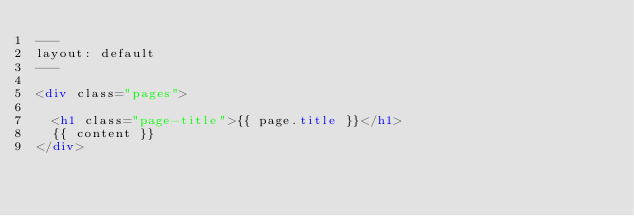Convert code to text. <code><loc_0><loc_0><loc_500><loc_500><_HTML_>---
layout: default
---

<div class="pages">

  <h1 class="page-title">{{ page.title }}</h1>
  {{ content }}
</div>
</code> 